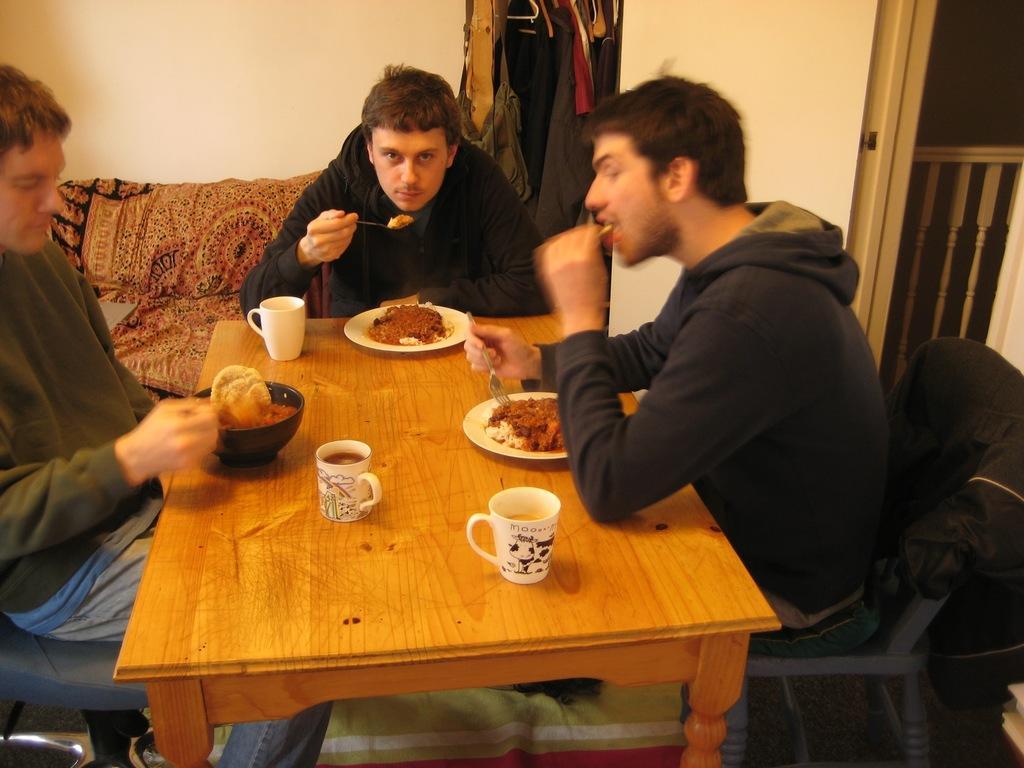How would you summarize this image in a sentence or two? In this image I can see three people are sitting in front of the table. On the table there is a plate with food,cups and spoons. To the back of this person there are clothes and to the left there is a railing. 